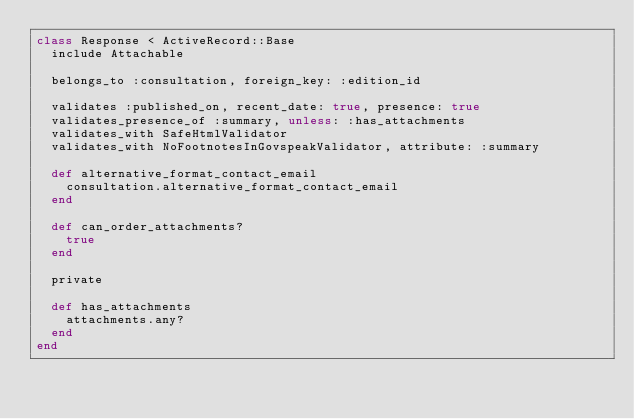<code> <loc_0><loc_0><loc_500><loc_500><_Ruby_>class Response < ActiveRecord::Base
  include Attachable

  belongs_to :consultation, foreign_key: :edition_id

  validates :published_on, recent_date: true, presence: true
  validates_presence_of :summary, unless: :has_attachments
  validates_with SafeHtmlValidator
  validates_with NoFootnotesInGovspeakValidator, attribute: :summary

  def alternative_format_contact_email
    consultation.alternative_format_contact_email
  end

  def can_order_attachments?
    true
  end

  private

  def has_attachments
    attachments.any?
  end
end
</code> 